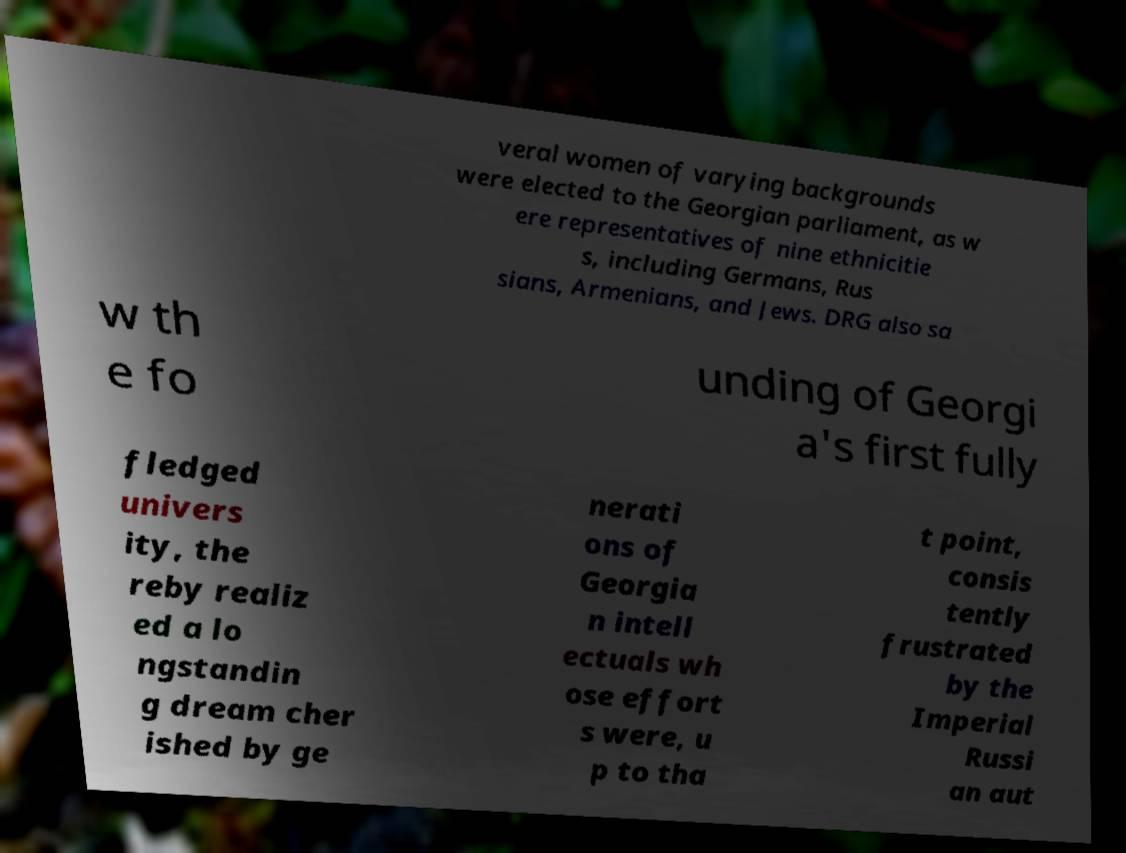Can you read and provide the text displayed in the image?This photo seems to have some interesting text. Can you extract and type it out for me? veral women of varying backgrounds were elected to the Georgian parliament, as w ere representatives of nine ethnicitie s, including Germans, Rus sians, Armenians, and Jews. DRG also sa w th e fo unding of Georgi a's first fully fledged univers ity, the reby realiz ed a lo ngstandin g dream cher ished by ge nerati ons of Georgia n intell ectuals wh ose effort s were, u p to tha t point, consis tently frustrated by the Imperial Russi an aut 